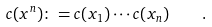Convert formula to latex. <formula><loc_0><loc_0><loc_500><loc_500>c ( x ^ { n } ) \colon = c ( x _ { 1 } ) \cdots c ( x _ { n } ) \quad .</formula> 